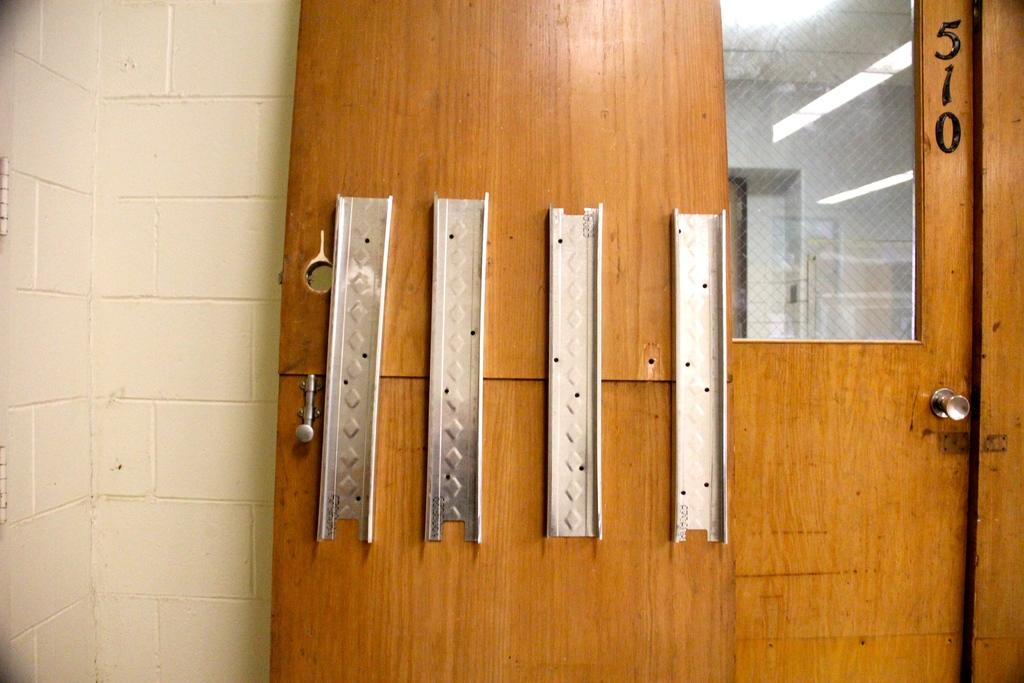What is the main object in the foreground of the image? There is a wooden door in the foreground of the image. What can be seen on the wooden door? There are metal objects on the wooden door. What is visible on the left side of the image? There is a wall on the left side of the image. What is present on the right side of the image? There is another wooden door on the right side of the image. What type of comfort can be seen being provided by the actor in the image? There is no actor present in the image, and therefore no comfort being provided. What type of cabbage is growing on the wall in the image? There is no cabbage present in the image, and the wall is not a growing area for plants. 